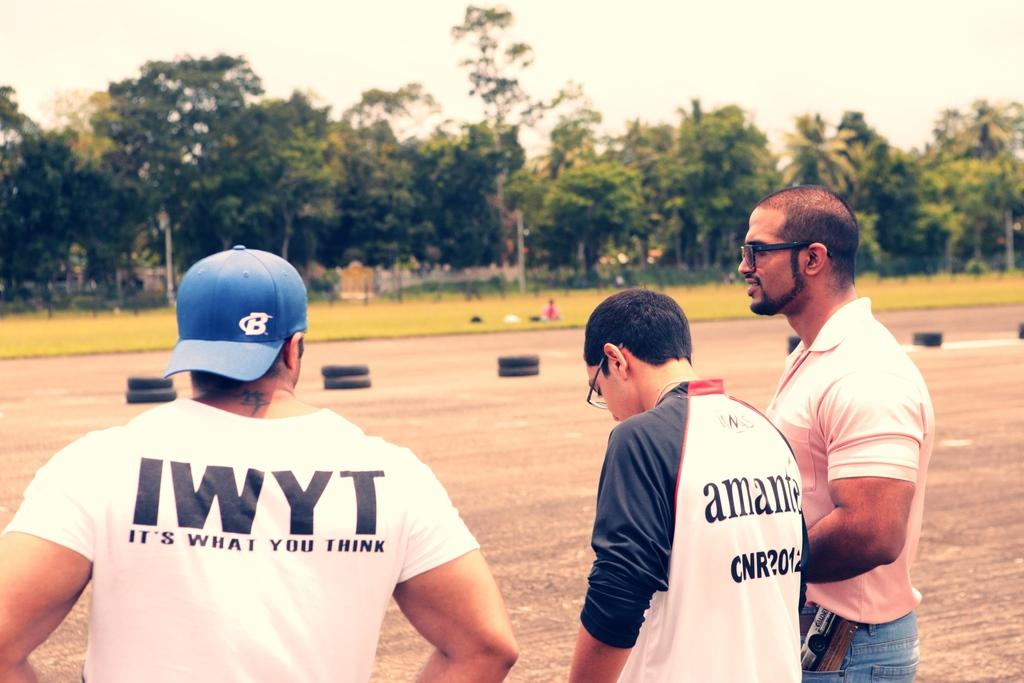<image>
Share a concise interpretation of the image provided. Three men stand on an open pavement, one wears a shirt with the letters IWYT on it. 